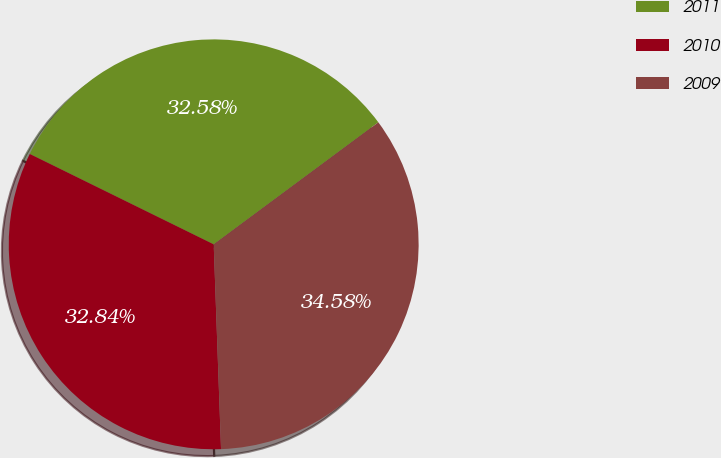<chart> <loc_0><loc_0><loc_500><loc_500><pie_chart><fcel>2011<fcel>2010<fcel>2009<nl><fcel>32.58%<fcel>32.84%<fcel>34.58%<nl></chart> 